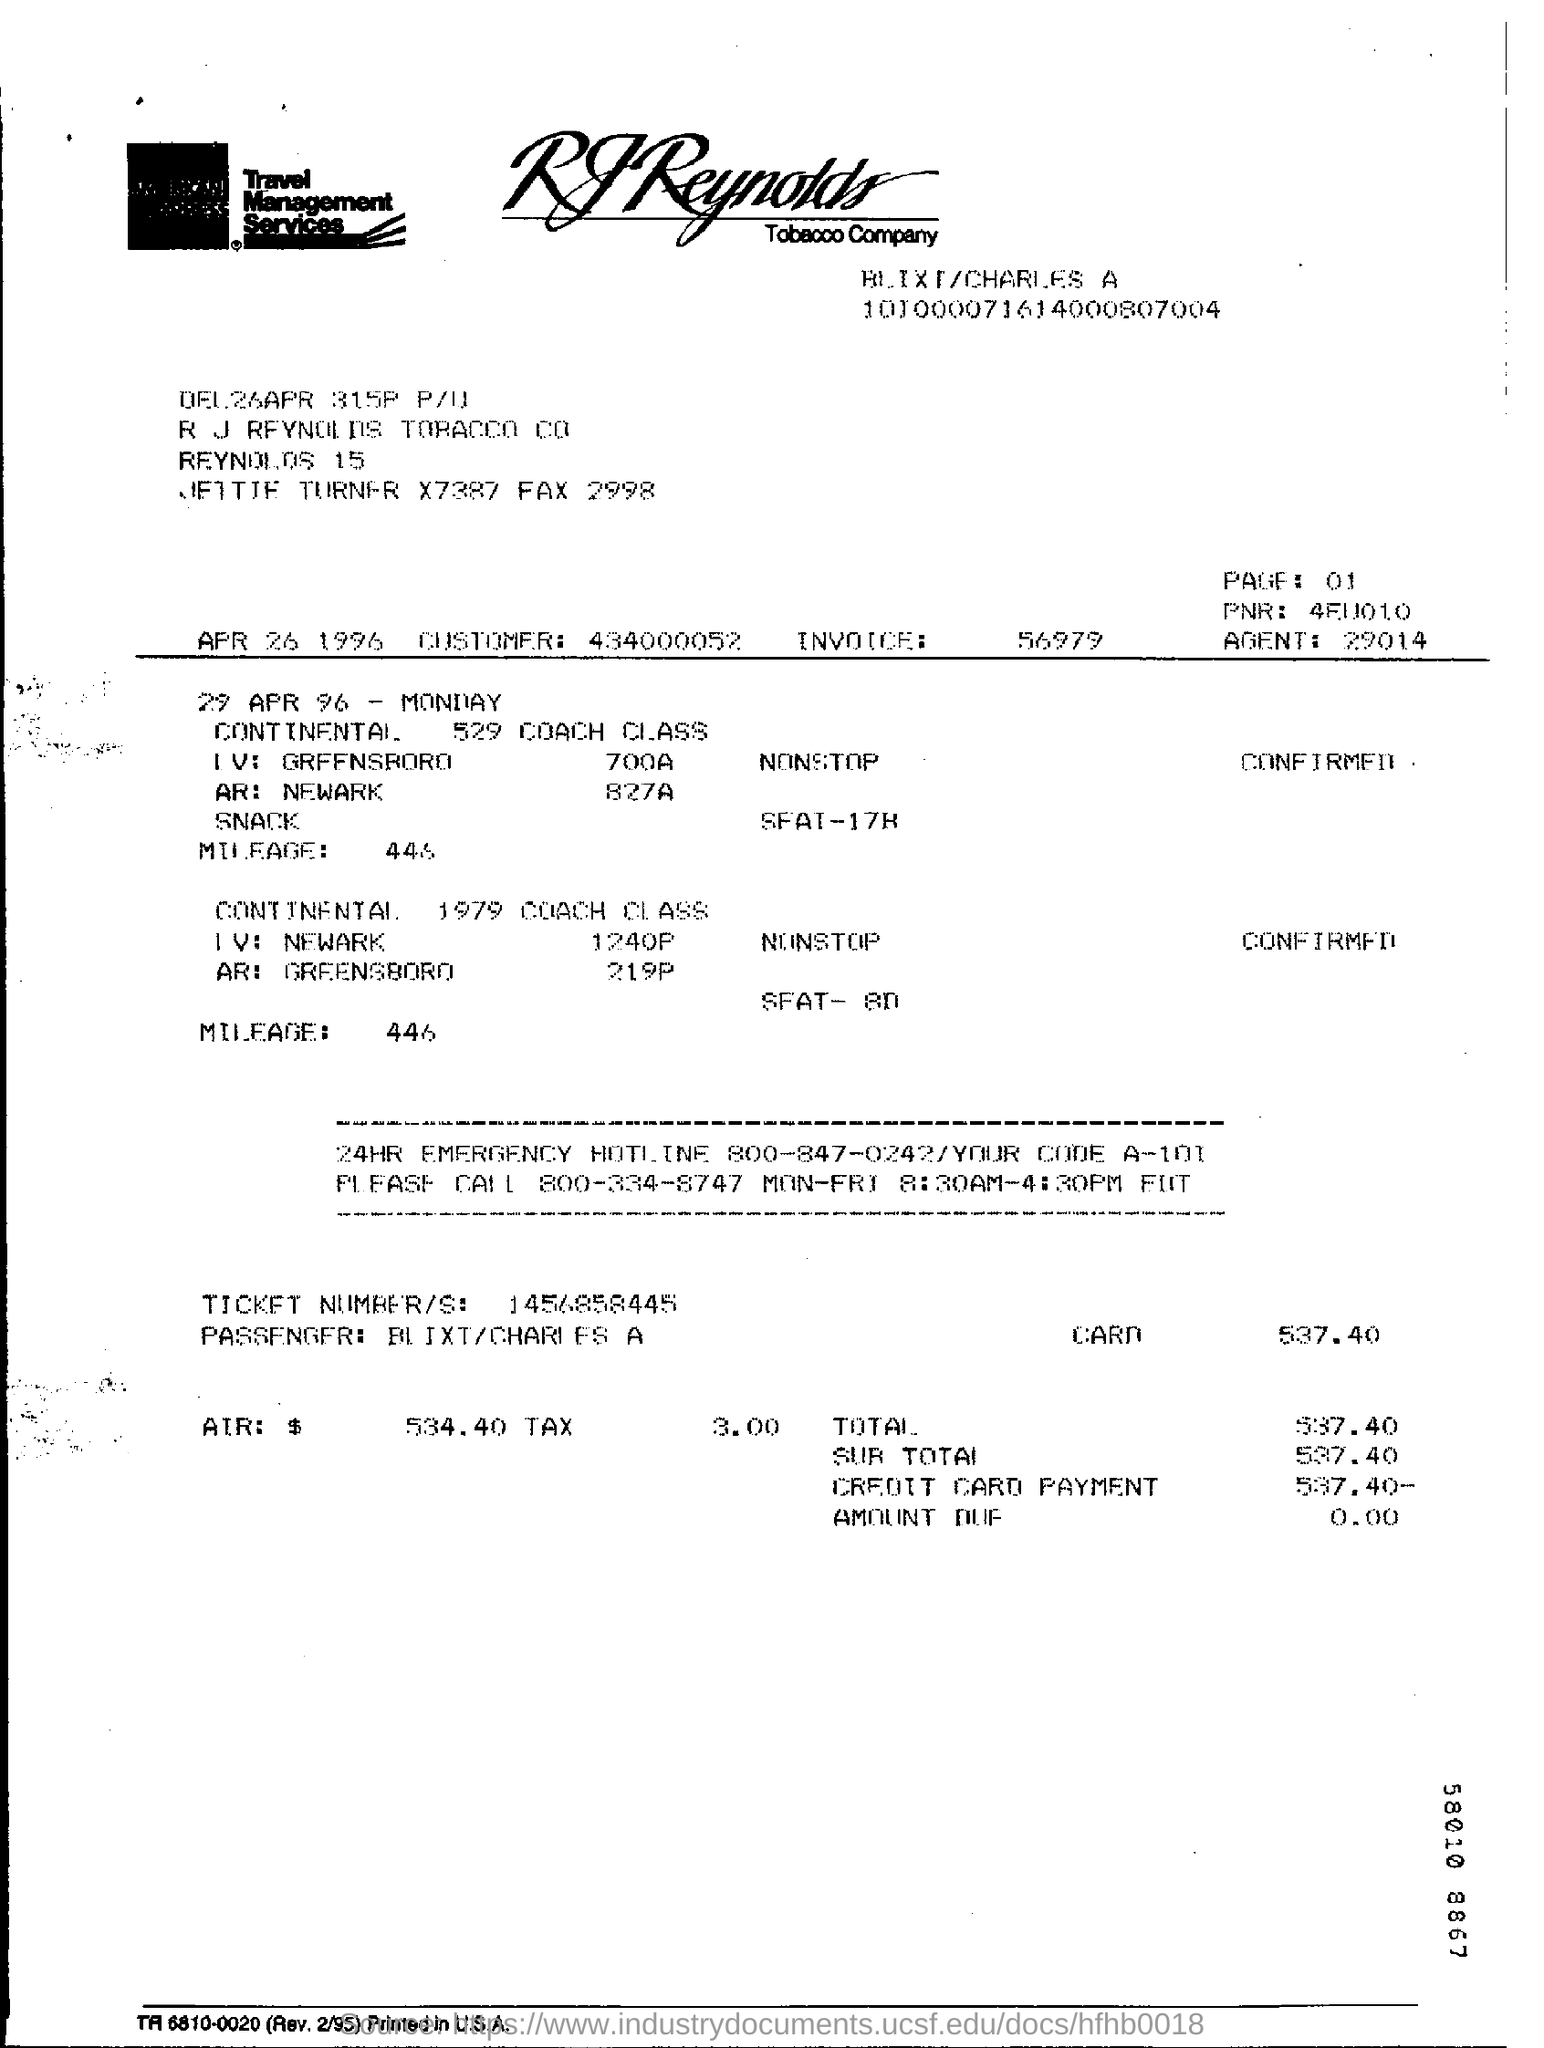Indicate a few pertinent items in this graphic. The total is 537.40 dollars. On April 29th, 1996, it was a Monday. The invoice number is 56979. 